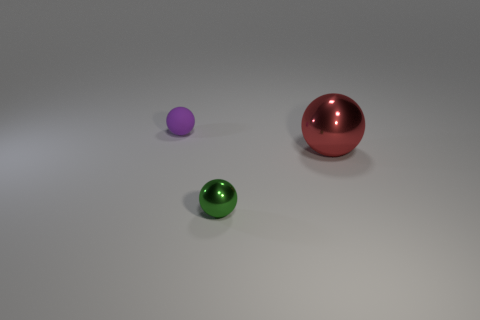Is the number of objects in front of the big metallic sphere greater than the number of big metallic things that are left of the small purple sphere?
Your answer should be very brief. Yes. What number of other objects are there of the same size as the purple matte sphere?
Keep it short and to the point. 1. What material is the thing that is behind the tiny green object and in front of the tiny matte thing?
Offer a very short reply. Metal. There is another green thing that is the same shape as the large object; what material is it?
Make the answer very short. Metal. There is a tiny thing that is in front of the shiny ball that is behind the small shiny sphere; what number of green metal spheres are on the left side of it?
Provide a short and direct response. 0. Is there anything else that has the same color as the tiny rubber object?
Provide a succinct answer. No. How many things are both behind the green metal sphere and in front of the small purple thing?
Offer a terse response. 1. Does the object that is in front of the large shiny object have the same size as the sphere that is on the left side of the small green ball?
Give a very brief answer. Yes. How many things are balls behind the large red metal object or big gray cubes?
Your answer should be compact. 1. There is a tiny sphere that is on the right side of the tiny purple rubber sphere; what material is it?
Offer a terse response. Metal. 